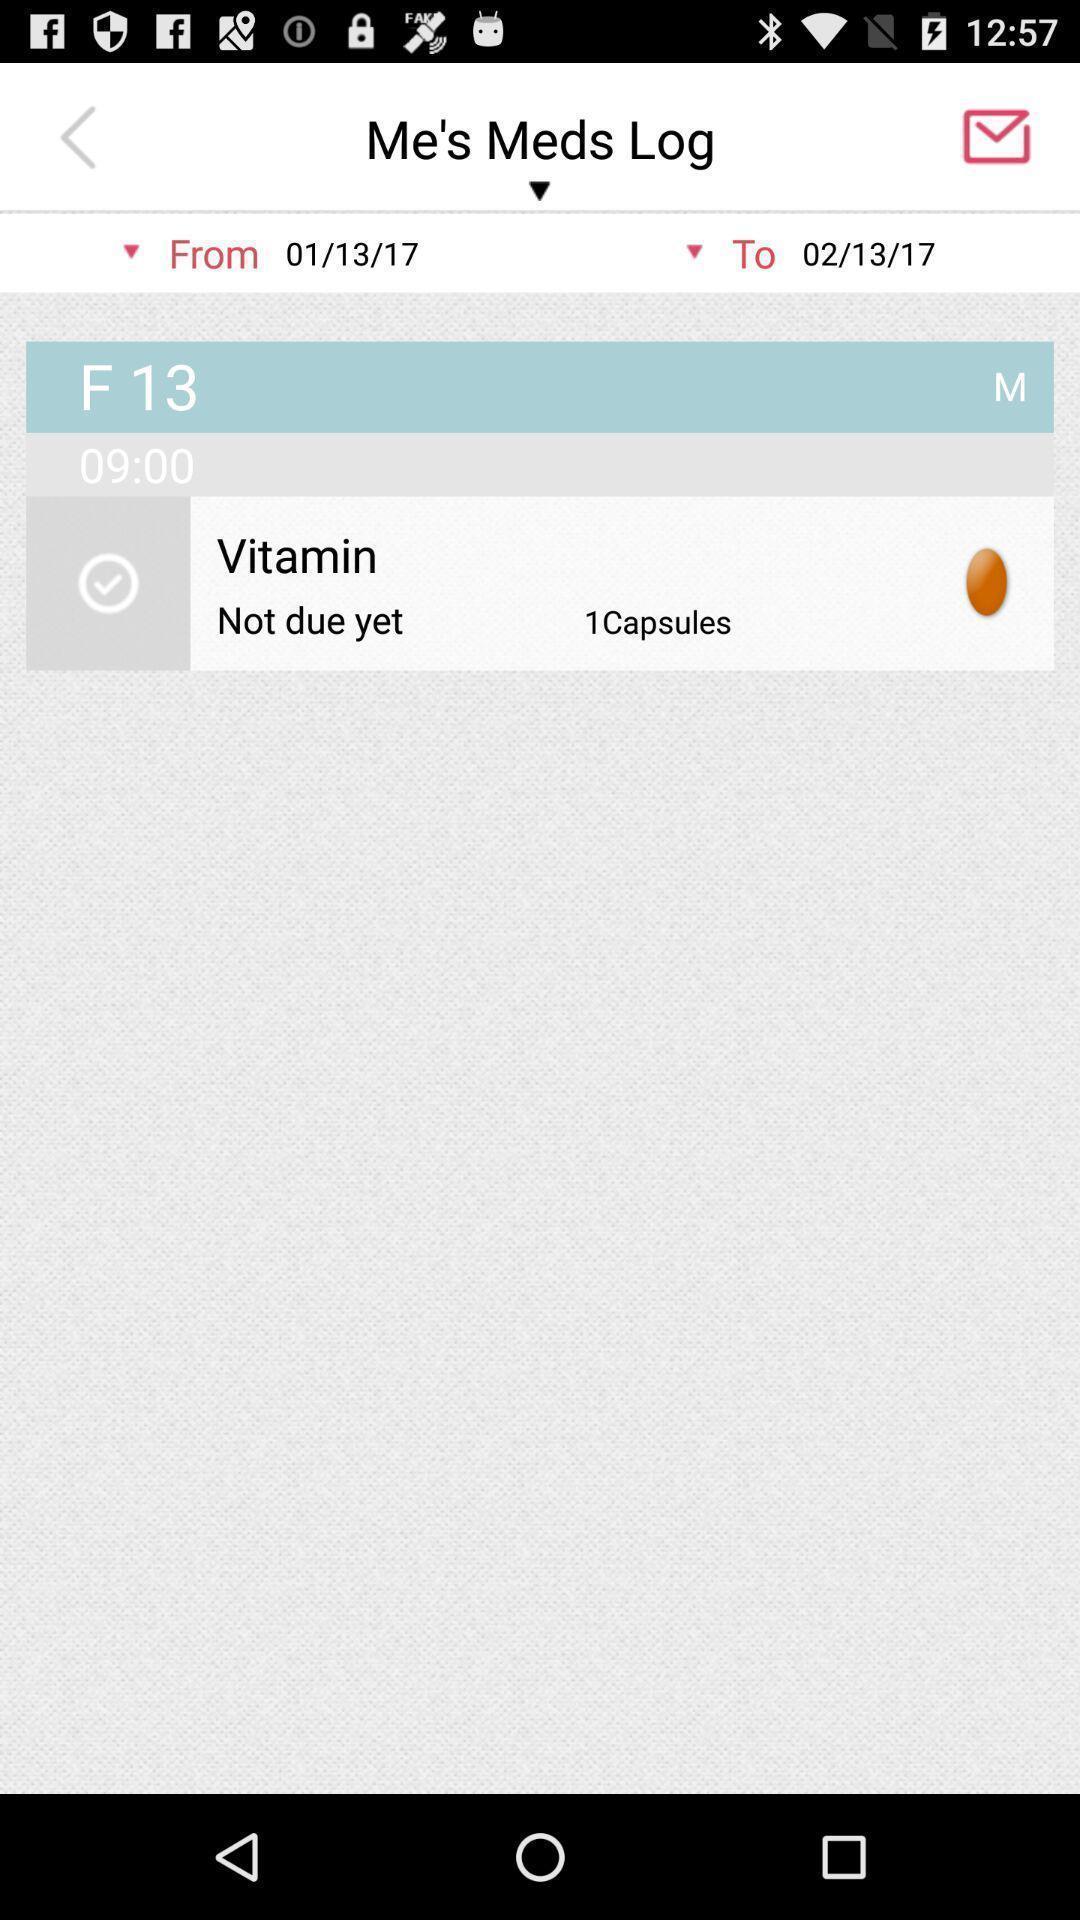What is the overall content of this screenshot? Page of me 's meds log of the app. 